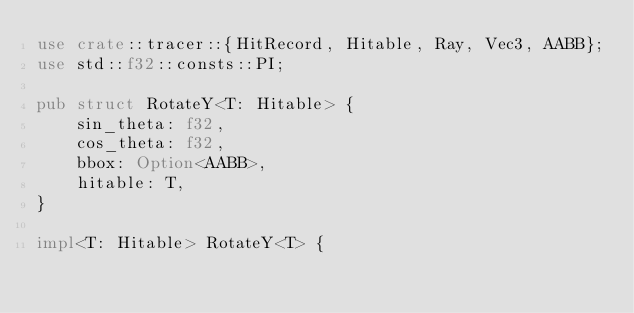Convert code to text. <code><loc_0><loc_0><loc_500><loc_500><_Rust_>use crate::tracer::{HitRecord, Hitable, Ray, Vec3, AABB};
use std::f32::consts::PI;

pub struct RotateY<T: Hitable> {
    sin_theta: f32,
    cos_theta: f32,
    bbox: Option<AABB>,
    hitable: T,
}

impl<T: Hitable> RotateY<T> {</code> 